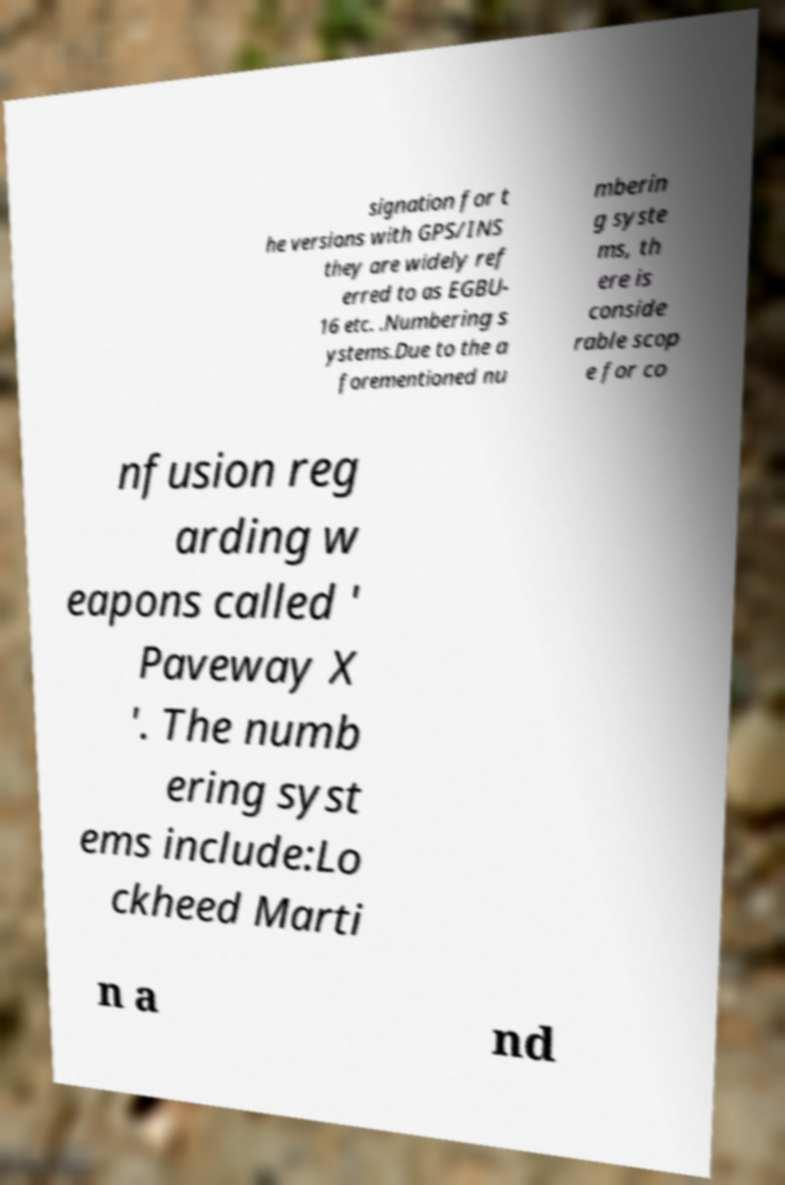There's text embedded in this image that I need extracted. Can you transcribe it verbatim? signation for t he versions with GPS/INS they are widely ref erred to as EGBU- 16 etc. .Numbering s ystems.Due to the a forementioned nu mberin g syste ms, th ere is conside rable scop e for co nfusion reg arding w eapons called ' Paveway X '. The numb ering syst ems include:Lo ckheed Marti n a nd 